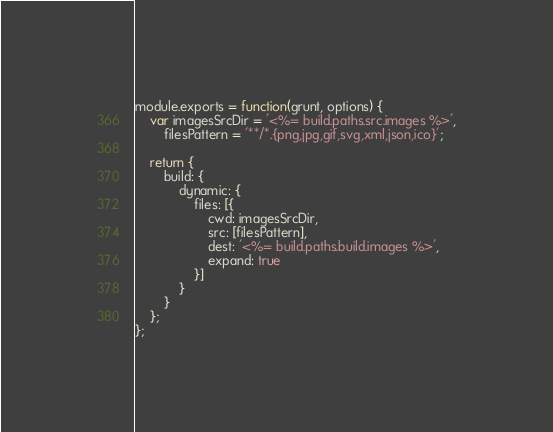Convert code to text. <code><loc_0><loc_0><loc_500><loc_500><_JavaScript_>module.exports = function(grunt, options) {
    var imagesSrcDir = '<%= build.paths.src.images %>',
        filesPattern = '**/*.{png,jpg,gif,svg,xml,json,ico}';
    
    return {
        build: {
            dynamic: {
                files: [{
                    cwd: imagesSrcDir,
                    src: [filesPattern],
                    dest: '<%= build.paths.build.images %>',
                    expand: true
                }]
            }
        }
    };
};</code> 